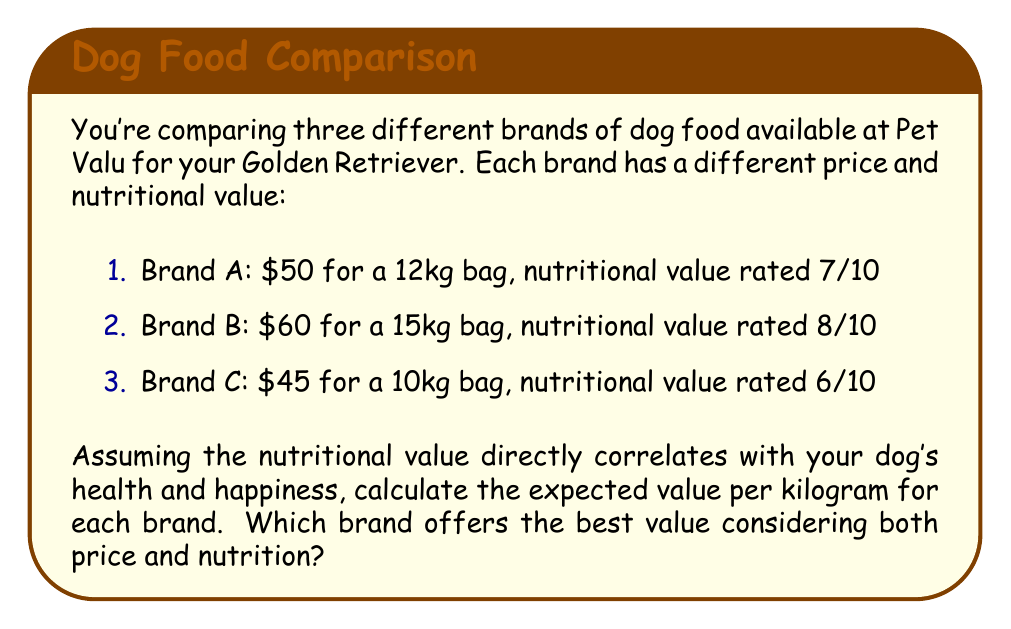Provide a solution to this math problem. To solve this problem, we need to calculate the expected value per kilogram for each brand, considering both price and nutritional value. We'll use the following formula:

$$ \text{Expected Value per kg} = \frac{\text{Nutritional Value}}{\text{Price per kg}} $$

Let's calculate the price per kg for each brand first:

1. Brand A: $\frac{$50}{12\text{kg}} = $4.17\text{ per kg}$
2. Brand B: $\frac{$60}{15\text{kg}} = $4.00\text{ per kg}$
3. Brand C: $\frac{$45}{10\text{kg}} = $4.50\text{ per kg}$

Now, let's calculate the expected value per kg for each brand:

1. Brand A: $\frac{7}{$4.17} = 1.68\text{ value per dollar per kg}$
2. Brand B: $\frac{8}{$4.00} = 2.00\text{ value per dollar per kg}$
3. Brand C: $\frac{6}{$4.50} = 1.33\text{ value per dollar per kg}$

The higher the expected value, the better the combination of nutrition and price.
Answer: Brand B offers the best value with an expected value of 2.00 per dollar per kg, followed by Brand A (1.68), and then Brand C (1.33). 